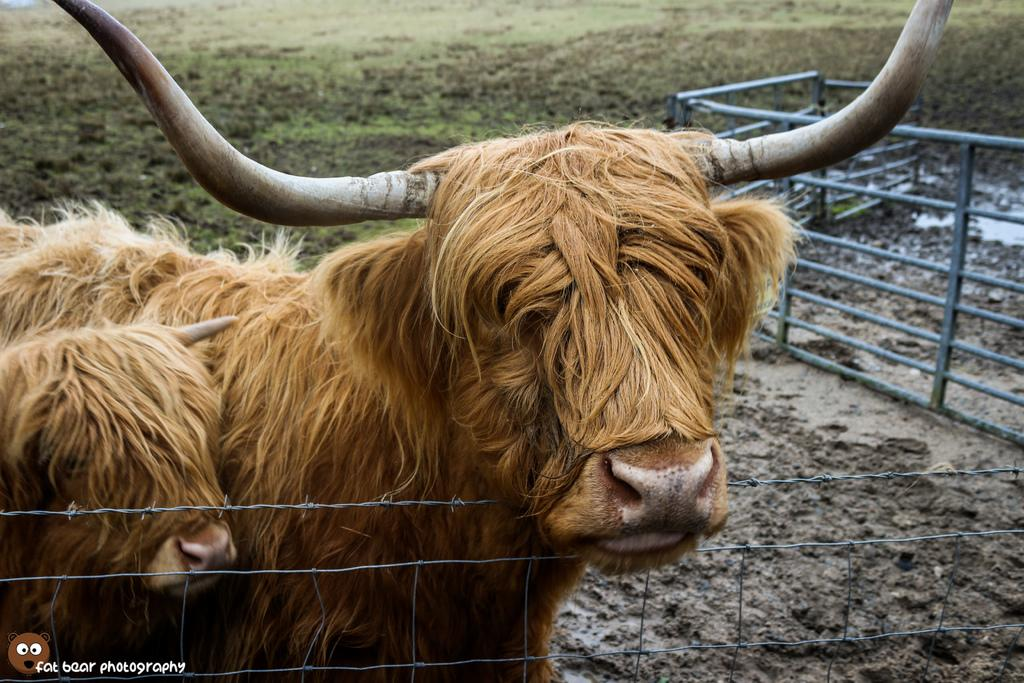What animals are in the foreground of the image? There are bulls in the foreground of the image. What is near the bulls in the image? The bulls are near a fencing. What can be seen in the background of the image? There is railing, mud, and grass in the background of the image. What type of rhythm can be heard coming from the bulls in the image? There is no sound or rhythm associated with the bulls in the image; they are stationary animals. 